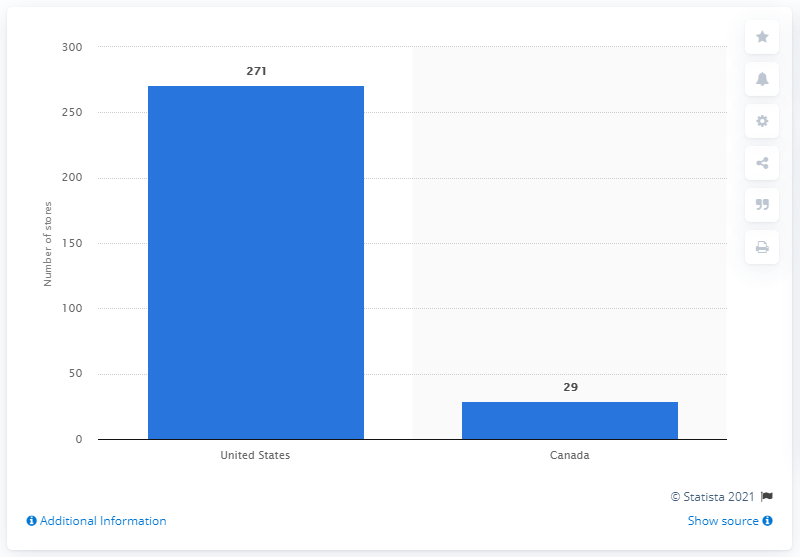Highlight a few significant elements in this photo. As of August 2020, there were 271 Apple retail stores in the United States. 